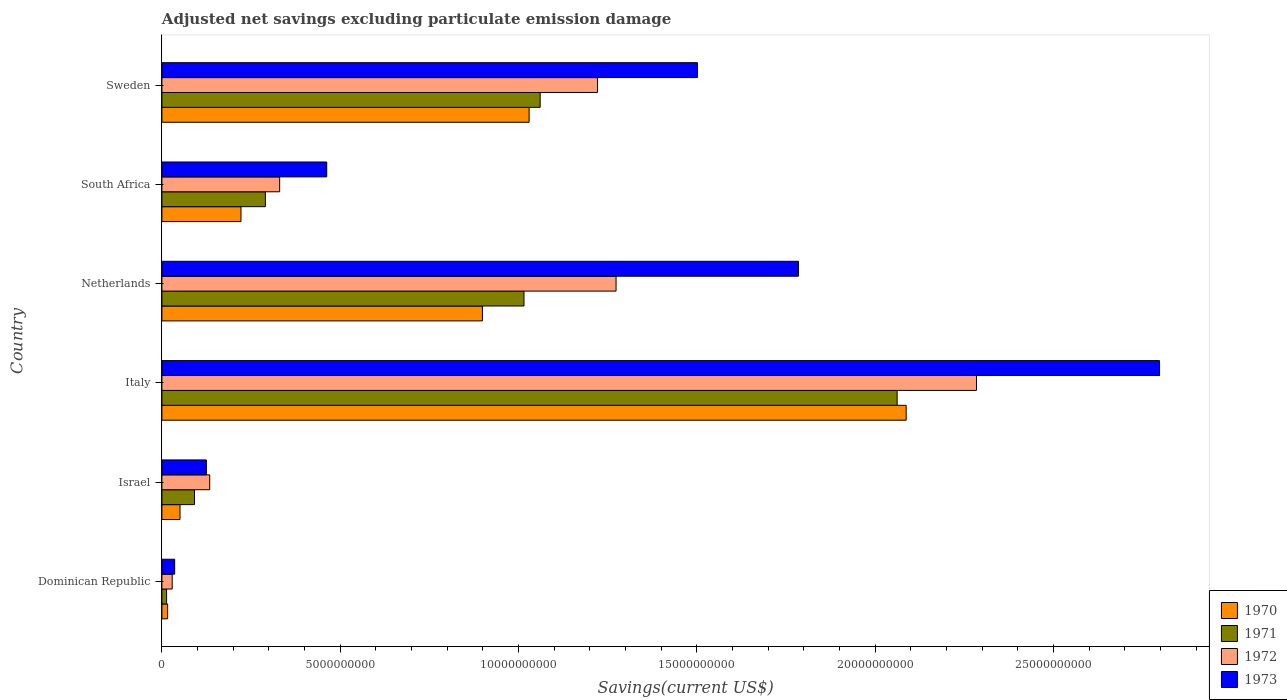How many different coloured bars are there?
Give a very brief answer. 4. How many bars are there on the 4th tick from the top?
Make the answer very short. 4. How many bars are there on the 5th tick from the bottom?
Provide a short and direct response. 4. What is the label of the 3rd group of bars from the top?
Give a very brief answer. Netherlands. In how many cases, is the number of bars for a given country not equal to the number of legend labels?
Make the answer very short. 0. What is the adjusted net savings in 1970 in Netherlands?
Provide a short and direct response. 8.99e+09. Across all countries, what is the maximum adjusted net savings in 1970?
Keep it short and to the point. 2.09e+1. Across all countries, what is the minimum adjusted net savings in 1972?
Provide a succinct answer. 2.89e+08. In which country was the adjusted net savings in 1971 minimum?
Offer a terse response. Dominican Republic. What is the total adjusted net savings in 1971 in the graph?
Give a very brief answer. 4.53e+1. What is the difference between the adjusted net savings in 1972 in Netherlands and that in Sweden?
Offer a very short reply. 5.20e+08. What is the difference between the adjusted net savings in 1971 in Italy and the adjusted net savings in 1972 in Sweden?
Your response must be concise. 8.40e+09. What is the average adjusted net savings in 1971 per country?
Give a very brief answer. 7.55e+09. What is the difference between the adjusted net savings in 1973 and adjusted net savings in 1970 in Israel?
Provide a succinct answer. 7.39e+08. What is the ratio of the adjusted net savings in 1973 in Italy to that in Sweden?
Your answer should be compact. 1.86. What is the difference between the highest and the second highest adjusted net savings in 1971?
Ensure brevity in your answer.  1.00e+1. What is the difference between the highest and the lowest adjusted net savings in 1972?
Ensure brevity in your answer.  2.26e+1. In how many countries, is the adjusted net savings in 1972 greater than the average adjusted net savings in 1972 taken over all countries?
Offer a terse response. 3. Is the sum of the adjusted net savings in 1973 in Netherlands and South Africa greater than the maximum adjusted net savings in 1971 across all countries?
Your response must be concise. Yes. Is it the case that in every country, the sum of the adjusted net savings in 1973 and adjusted net savings in 1971 is greater than the sum of adjusted net savings in 1970 and adjusted net savings in 1972?
Your answer should be compact. No. What does the 2nd bar from the top in South Africa represents?
Your response must be concise. 1972. What does the 2nd bar from the bottom in Dominican Republic represents?
Keep it short and to the point. 1971. Is it the case that in every country, the sum of the adjusted net savings in 1972 and adjusted net savings in 1970 is greater than the adjusted net savings in 1973?
Provide a short and direct response. Yes. Are all the bars in the graph horizontal?
Your response must be concise. Yes. What is the difference between two consecutive major ticks on the X-axis?
Provide a short and direct response. 5.00e+09. Does the graph contain grids?
Your response must be concise. No. How many legend labels are there?
Give a very brief answer. 4. What is the title of the graph?
Make the answer very short. Adjusted net savings excluding particulate emission damage. What is the label or title of the X-axis?
Ensure brevity in your answer.  Savings(current US$). What is the Savings(current US$) of 1970 in Dominican Republic?
Your response must be concise. 1.61e+08. What is the Savings(current US$) of 1971 in Dominican Republic?
Provide a short and direct response. 1.32e+08. What is the Savings(current US$) of 1972 in Dominican Republic?
Provide a short and direct response. 2.89e+08. What is the Savings(current US$) of 1973 in Dominican Republic?
Keep it short and to the point. 3.58e+08. What is the Savings(current US$) in 1970 in Israel?
Your answer should be compact. 5.08e+08. What is the Savings(current US$) of 1971 in Israel?
Make the answer very short. 9.14e+08. What is the Savings(current US$) in 1972 in Israel?
Your answer should be compact. 1.34e+09. What is the Savings(current US$) in 1973 in Israel?
Your answer should be very brief. 1.25e+09. What is the Savings(current US$) of 1970 in Italy?
Your response must be concise. 2.09e+1. What is the Savings(current US$) of 1971 in Italy?
Your answer should be very brief. 2.06e+1. What is the Savings(current US$) of 1972 in Italy?
Your response must be concise. 2.28e+1. What is the Savings(current US$) of 1973 in Italy?
Provide a succinct answer. 2.80e+1. What is the Savings(current US$) of 1970 in Netherlands?
Your response must be concise. 8.99e+09. What is the Savings(current US$) in 1971 in Netherlands?
Offer a very short reply. 1.02e+1. What is the Savings(current US$) of 1972 in Netherlands?
Your answer should be very brief. 1.27e+1. What is the Savings(current US$) in 1973 in Netherlands?
Provide a succinct answer. 1.79e+1. What is the Savings(current US$) of 1970 in South Africa?
Your answer should be very brief. 2.22e+09. What is the Savings(current US$) in 1971 in South Africa?
Provide a succinct answer. 2.90e+09. What is the Savings(current US$) of 1972 in South Africa?
Ensure brevity in your answer.  3.30e+09. What is the Savings(current US$) in 1973 in South Africa?
Make the answer very short. 4.62e+09. What is the Savings(current US$) of 1970 in Sweden?
Offer a very short reply. 1.03e+1. What is the Savings(current US$) of 1971 in Sweden?
Ensure brevity in your answer.  1.06e+1. What is the Savings(current US$) of 1972 in Sweden?
Your answer should be very brief. 1.22e+1. What is the Savings(current US$) in 1973 in Sweden?
Your answer should be very brief. 1.50e+1. Across all countries, what is the maximum Savings(current US$) of 1970?
Offer a terse response. 2.09e+1. Across all countries, what is the maximum Savings(current US$) in 1971?
Make the answer very short. 2.06e+1. Across all countries, what is the maximum Savings(current US$) in 1972?
Make the answer very short. 2.28e+1. Across all countries, what is the maximum Savings(current US$) of 1973?
Offer a terse response. 2.80e+1. Across all countries, what is the minimum Savings(current US$) in 1970?
Offer a terse response. 1.61e+08. Across all countries, what is the minimum Savings(current US$) of 1971?
Ensure brevity in your answer.  1.32e+08. Across all countries, what is the minimum Savings(current US$) of 1972?
Ensure brevity in your answer.  2.89e+08. Across all countries, what is the minimum Savings(current US$) in 1973?
Your answer should be very brief. 3.58e+08. What is the total Savings(current US$) of 1970 in the graph?
Provide a short and direct response. 4.30e+1. What is the total Savings(current US$) in 1971 in the graph?
Keep it short and to the point. 4.53e+1. What is the total Savings(current US$) in 1972 in the graph?
Provide a short and direct response. 5.27e+1. What is the total Savings(current US$) of 1973 in the graph?
Your answer should be compact. 6.71e+1. What is the difference between the Savings(current US$) of 1970 in Dominican Republic and that in Israel?
Keep it short and to the point. -3.47e+08. What is the difference between the Savings(current US$) of 1971 in Dominican Republic and that in Israel?
Your response must be concise. -7.83e+08. What is the difference between the Savings(current US$) of 1972 in Dominican Republic and that in Israel?
Your response must be concise. -1.05e+09. What is the difference between the Savings(current US$) of 1973 in Dominican Republic and that in Israel?
Make the answer very short. -8.89e+08. What is the difference between the Savings(current US$) of 1970 in Dominican Republic and that in Italy?
Make the answer very short. -2.07e+1. What is the difference between the Savings(current US$) of 1971 in Dominican Republic and that in Italy?
Offer a very short reply. -2.05e+1. What is the difference between the Savings(current US$) in 1972 in Dominican Republic and that in Italy?
Offer a terse response. -2.26e+1. What is the difference between the Savings(current US$) in 1973 in Dominican Republic and that in Italy?
Give a very brief answer. -2.76e+1. What is the difference between the Savings(current US$) of 1970 in Dominican Republic and that in Netherlands?
Your answer should be very brief. -8.83e+09. What is the difference between the Savings(current US$) in 1971 in Dominican Republic and that in Netherlands?
Give a very brief answer. -1.00e+1. What is the difference between the Savings(current US$) in 1972 in Dominican Republic and that in Netherlands?
Ensure brevity in your answer.  -1.24e+1. What is the difference between the Savings(current US$) in 1973 in Dominican Republic and that in Netherlands?
Provide a succinct answer. -1.75e+1. What is the difference between the Savings(current US$) in 1970 in Dominican Republic and that in South Africa?
Make the answer very short. -2.06e+09. What is the difference between the Savings(current US$) of 1971 in Dominican Republic and that in South Africa?
Provide a short and direct response. -2.77e+09. What is the difference between the Savings(current US$) of 1972 in Dominican Republic and that in South Africa?
Provide a succinct answer. -3.01e+09. What is the difference between the Savings(current US$) in 1973 in Dominican Republic and that in South Africa?
Provide a short and direct response. -4.26e+09. What is the difference between the Savings(current US$) in 1970 in Dominican Republic and that in Sweden?
Your response must be concise. -1.01e+1. What is the difference between the Savings(current US$) of 1971 in Dominican Republic and that in Sweden?
Keep it short and to the point. -1.05e+1. What is the difference between the Savings(current US$) of 1972 in Dominican Republic and that in Sweden?
Your response must be concise. -1.19e+1. What is the difference between the Savings(current US$) of 1973 in Dominican Republic and that in Sweden?
Your response must be concise. -1.47e+1. What is the difference between the Savings(current US$) in 1970 in Israel and that in Italy?
Provide a short and direct response. -2.04e+1. What is the difference between the Savings(current US$) in 1971 in Israel and that in Italy?
Provide a short and direct response. -1.97e+1. What is the difference between the Savings(current US$) of 1972 in Israel and that in Italy?
Ensure brevity in your answer.  -2.15e+1. What is the difference between the Savings(current US$) of 1973 in Israel and that in Italy?
Make the answer very short. -2.67e+1. What is the difference between the Savings(current US$) of 1970 in Israel and that in Netherlands?
Your response must be concise. -8.48e+09. What is the difference between the Savings(current US$) of 1971 in Israel and that in Netherlands?
Your answer should be compact. -9.24e+09. What is the difference between the Savings(current US$) of 1972 in Israel and that in Netherlands?
Your answer should be compact. -1.14e+1. What is the difference between the Savings(current US$) in 1973 in Israel and that in Netherlands?
Your response must be concise. -1.66e+1. What is the difference between the Savings(current US$) in 1970 in Israel and that in South Africa?
Give a very brief answer. -1.71e+09. What is the difference between the Savings(current US$) of 1971 in Israel and that in South Africa?
Provide a succinct answer. -1.99e+09. What is the difference between the Savings(current US$) in 1972 in Israel and that in South Africa?
Your response must be concise. -1.96e+09. What is the difference between the Savings(current US$) in 1973 in Israel and that in South Africa?
Keep it short and to the point. -3.38e+09. What is the difference between the Savings(current US$) in 1970 in Israel and that in Sweden?
Provide a short and direct response. -9.79e+09. What is the difference between the Savings(current US$) in 1971 in Israel and that in Sweden?
Ensure brevity in your answer.  -9.69e+09. What is the difference between the Savings(current US$) of 1972 in Israel and that in Sweden?
Offer a very short reply. -1.09e+1. What is the difference between the Savings(current US$) of 1973 in Israel and that in Sweden?
Your answer should be very brief. -1.38e+1. What is the difference between the Savings(current US$) in 1970 in Italy and that in Netherlands?
Provide a short and direct response. 1.19e+1. What is the difference between the Savings(current US$) of 1971 in Italy and that in Netherlands?
Your response must be concise. 1.05e+1. What is the difference between the Savings(current US$) in 1972 in Italy and that in Netherlands?
Offer a terse response. 1.01e+1. What is the difference between the Savings(current US$) of 1973 in Italy and that in Netherlands?
Keep it short and to the point. 1.01e+1. What is the difference between the Savings(current US$) of 1970 in Italy and that in South Africa?
Make the answer very short. 1.87e+1. What is the difference between the Savings(current US$) of 1971 in Italy and that in South Africa?
Give a very brief answer. 1.77e+1. What is the difference between the Savings(current US$) in 1972 in Italy and that in South Africa?
Ensure brevity in your answer.  1.95e+1. What is the difference between the Savings(current US$) in 1973 in Italy and that in South Africa?
Ensure brevity in your answer.  2.34e+1. What is the difference between the Savings(current US$) in 1970 in Italy and that in Sweden?
Your response must be concise. 1.06e+1. What is the difference between the Savings(current US$) of 1971 in Italy and that in Sweden?
Make the answer very short. 1.00e+1. What is the difference between the Savings(current US$) of 1972 in Italy and that in Sweden?
Provide a short and direct response. 1.06e+1. What is the difference between the Savings(current US$) of 1973 in Italy and that in Sweden?
Provide a succinct answer. 1.30e+1. What is the difference between the Savings(current US$) in 1970 in Netherlands and that in South Africa?
Keep it short and to the point. 6.77e+09. What is the difference between the Savings(current US$) of 1971 in Netherlands and that in South Africa?
Your answer should be compact. 7.25e+09. What is the difference between the Savings(current US$) in 1972 in Netherlands and that in South Africa?
Your answer should be very brief. 9.43e+09. What is the difference between the Savings(current US$) of 1973 in Netherlands and that in South Africa?
Provide a succinct answer. 1.32e+1. What is the difference between the Savings(current US$) in 1970 in Netherlands and that in Sweden?
Your response must be concise. -1.31e+09. What is the difference between the Savings(current US$) of 1971 in Netherlands and that in Sweden?
Offer a terse response. -4.54e+08. What is the difference between the Savings(current US$) of 1972 in Netherlands and that in Sweden?
Make the answer very short. 5.20e+08. What is the difference between the Savings(current US$) of 1973 in Netherlands and that in Sweden?
Your answer should be very brief. 2.83e+09. What is the difference between the Savings(current US$) in 1970 in South Africa and that in Sweden?
Make the answer very short. -8.08e+09. What is the difference between the Savings(current US$) in 1971 in South Africa and that in Sweden?
Your response must be concise. -7.70e+09. What is the difference between the Savings(current US$) of 1972 in South Africa and that in Sweden?
Your response must be concise. -8.91e+09. What is the difference between the Savings(current US$) of 1973 in South Africa and that in Sweden?
Give a very brief answer. -1.04e+1. What is the difference between the Savings(current US$) of 1970 in Dominican Republic and the Savings(current US$) of 1971 in Israel?
Ensure brevity in your answer.  -7.53e+08. What is the difference between the Savings(current US$) of 1970 in Dominican Republic and the Savings(current US$) of 1972 in Israel?
Provide a succinct answer. -1.18e+09. What is the difference between the Savings(current US$) of 1970 in Dominican Republic and the Savings(current US$) of 1973 in Israel?
Give a very brief answer. -1.09e+09. What is the difference between the Savings(current US$) in 1971 in Dominican Republic and the Savings(current US$) in 1972 in Israel?
Your response must be concise. -1.21e+09. What is the difference between the Savings(current US$) in 1971 in Dominican Republic and the Savings(current US$) in 1973 in Israel?
Give a very brief answer. -1.12e+09. What is the difference between the Savings(current US$) of 1972 in Dominican Republic and the Savings(current US$) of 1973 in Israel?
Offer a terse response. -9.58e+08. What is the difference between the Savings(current US$) of 1970 in Dominican Republic and the Savings(current US$) of 1971 in Italy?
Provide a succinct answer. -2.05e+1. What is the difference between the Savings(current US$) in 1970 in Dominican Republic and the Savings(current US$) in 1972 in Italy?
Ensure brevity in your answer.  -2.27e+1. What is the difference between the Savings(current US$) in 1970 in Dominican Republic and the Savings(current US$) in 1973 in Italy?
Provide a succinct answer. -2.78e+1. What is the difference between the Savings(current US$) in 1971 in Dominican Republic and the Savings(current US$) in 1972 in Italy?
Make the answer very short. -2.27e+1. What is the difference between the Savings(current US$) of 1971 in Dominican Republic and the Savings(current US$) of 1973 in Italy?
Provide a succinct answer. -2.78e+1. What is the difference between the Savings(current US$) of 1972 in Dominican Republic and the Savings(current US$) of 1973 in Italy?
Ensure brevity in your answer.  -2.77e+1. What is the difference between the Savings(current US$) in 1970 in Dominican Republic and the Savings(current US$) in 1971 in Netherlands?
Offer a very short reply. -9.99e+09. What is the difference between the Savings(current US$) of 1970 in Dominican Republic and the Savings(current US$) of 1972 in Netherlands?
Make the answer very short. -1.26e+1. What is the difference between the Savings(current US$) in 1970 in Dominican Republic and the Savings(current US$) in 1973 in Netherlands?
Your answer should be very brief. -1.77e+1. What is the difference between the Savings(current US$) in 1971 in Dominican Republic and the Savings(current US$) in 1972 in Netherlands?
Your answer should be very brief. -1.26e+1. What is the difference between the Savings(current US$) of 1971 in Dominican Republic and the Savings(current US$) of 1973 in Netherlands?
Offer a terse response. -1.77e+1. What is the difference between the Savings(current US$) of 1972 in Dominican Republic and the Savings(current US$) of 1973 in Netherlands?
Provide a short and direct response. -1.76e+1. What is the difference between the Savings(current US$) of 1970 in Dominican Republic and the Savings(current US$) of 1971 in South Africa?
Offer a terse response. -2.74e+09. What is the difference between the Savings(current US$) in 1970 in Dominican Republic and the Savings(current US$) in 1972 in South Africa?
Offer a terse response. -3.14e+09. What is the difference between the Savings(current US$) in 1970 in Dominican Republic and the Savings(current US$) in 1973 in South Africa?
Your answer should be compact. -4.46e+09. What is the difference between the Savings(current US$) of 1971 in Dominican Republic and the Savings(current US$) of 1972 in South Africa?
Keep it short and to the point. -3.17e+09. What is the difference between the Savings(current US$) of 1971 in Dominican Republic and the Savings(current US$) of 1973 in South Africa?
Offer a very short reply. -4.49e+09. What is the difference between the Savings(current US$) in 1972 in Dominican Republic and the Savings(current US$) in 1973 in South Africa?
Make the answer very short. -4.33e+09. What is the difference between the Savings(current US$) of 1970 in Dominican Republic and the Savings(current US$) of 1971 in Sweden?
Make the answer very short. -1.04e+1. What is the difference between the Savings(current US$) of 1970 in Dominican Republic and the Savings(current US$) of 1972 in Sweden?
Offer a very short reply. -1.21e+1. What is the difference between the Savings(current US$) in 1970 in Dominican Republic and the Savings(current US$) in 1973 in Sweden?
Keep it short and to the point. -1.49e+1. What is the difference between the Savings(current US$) in 1971 in Dominican Republic and the Savings(current US$) in 1972 in Sweden?
Your response must be concise. -1.21e+1. What is the difference between the Savings(current US$) in 1971 in Dominican Republic and the Savings(current US$) in 1973 in Sweden?
Your answer should be compact. -1.49e+1. What is the difference between the Savings(current US$) in 1972 in Dominican Republic and the Savings(current US$) in 1973 in Sweden?
Keep it short and to the point. -1.47e+1. What is the difference between the Savings(current US$) of 1970 in Israel and the Savings(current US$) of 1971 in Italy?
Keep it short and to the point. -2.01e+1. What is the difference between the Savings(current US$) in 1970 in Israel and the Savings(current US$) in 1972 in Italy?
Give a very brief answer. -2.23e+1. What is the difference between the Savings(current US$) in 1970 in Israel and the Savings(current US$) in 1973 in Italy?
Make the answer very short. -2.75e+1. What is the difference between the Savings(current US$) of 1971 in Israel and the Savings(current US$) of 1972 in Italy?
Offer a very short reply. -2.19e+1. What is the difference between the Savings(current US$) in 1971 in Israel and the Savings(current US$) in 1973 in Italy?
Your answer should be very brief. -2.71e+1. What is the difference between the Savings(current US$) in 1972 in Israel and the Savings(current US$) in 1973 in Italy?
Your answer should be compact. -2.66e+1. What is the difference between the Savings(current US$) of 1970 in Israel and the Savings(current US$) of 1971 in Netherlands?
Offer a terse response. -9.65e+09. What is the difference between the Savings(current US$) of 1970 in Israel and the Savings(current US$) of 1972 in Netherlands?
Offer a very short reply. -1.22e+1. What is the difference between the Savings(current US$) of 1970 in Israel and the Savings(current US$) of 1973 in Netherlands?
Provide a short and direct response. -1.73e+1. What is the difference between the Savings(current US$) of 1971 in Israel and the Savings(current US$) of 1972 in Netherlands?
Offer a very short reply. -1.18e+1. What is the difference between the Savings(current US$) of 1971 in Israel and the Savings(current US$) of 1973 in Netherlands?
Make the answer very short. -1.69e+1. What is the difference between the Savings(current US$) of 1972 in Israel and the Savings(current US$) of 1973 in Netherlands?
Provide a short and direct response. -1.65e+1. What is the difference between the Savings(current US$) in 1970 in Israel and the Savings(current US$) in 1971 in South Africa?
Provide a short and direct response. -2.39e+09. What is the difference between the Savings(current US$) in 1970 in Israel and the Savings(current US$) in 1972 in South Africa?
Your response must be concise. -2.79e+09. What is the difference between the Savings(current US$) in 1970 in Israel and the Savings(current US$) in 1973 in South Africa?
Keep it short and to the point. -4.11e+09. What is the difference between the Savings(current US$) of 1971 in Israel and the Savings(current US$) of 1972 in South Africa?
Make the answer very short. -2.39e+09. What is the difference between the Savings(current US$) in 1971 in Israel and the Savings(current US$) in 1973 in South Africa?
Your response must be concise. -3.71e+09. What is the difference between the Savings(current US$) in 1972 in Israel and the Savings(current US$) in 1973 in South Africa?
Keep it short and to the point. -3.28e+09. What is the difference between the Savings(current US$) of 1970 in Israel and the Savings(current US$) of 1971 in Sweden?
Provide a short and direct response. -1.01e+1. What is the difference between the Savings(current US$) in 1970 in Israel and the Savings(current US$) in 1972 in Sweden?
Keep it short and to the point. -1.17e+1. What is the difference between the Savings(current US$) of 1970 in Israel and the Savings(current US$) of 1973 in Sweden?
Provide a short and direct response. -1.45e+1. What is the difference between the Savings(current US$) in 1971 in Israel and the Savings(current US$) in 1972 in Sweden?
Your answer should be compact. -1.13e+1. What is the difference between the Savings(current US$) of 1971 in Israel and the Savings(current US$) of 1973 in Sweden?
Your answer should be compact. -1.41e+1. What is the difference between the Savings(current US$) of 1972 in Israel and the Savings(current US$) of 1973 in Sweden?
Keep it short and to the point. -1.37e+1. What is the difference between the Savings(current US$) of 1970 in Italy and the Savings(current US$) of 1971 in Netherlands?
Provide a short and direct response. 1.07e+1. What is the difference between the Savings(current US$) of 1970 in Italy and the Savings(current US$) of 1972 in Netherlands?
Keep it short and to the point. 8.14e+09. What is the difference between the Savings(current US$) in 1970 in Italy and the Savings(current US$) in 1973 in Netherlands?
Your response must be concise. 3.02e+09. What is the difference between the Savings(current US$) in 1971 in Italy and the Savings(current US$) in 1972 in Netherlands?
Give a very brief answer. 7.88e+09. What is the difference between the Savings(current US$) of 1971 in Italy and the Savings(current US$) of 1973 in Netherlands?
Ensure brevity in your answer.  2.77e+09. What is the difference between the Savings(current US$) in 1972 in Italy and the Savings(current US$) in 1973 in Netherlands?
Ensure brevity in your answer.  4.99e+09. What is the difference between the Savings(current US$) of 1970 in Italy and the Savings(current US$) of 1971 in South Africa?
Your answer should be very brief. 1.80e+1. What is the difference between the Savings(current US$) of 1970 in Italy and the Savings(current US$) of 1972 in South Africa?
Your answer should be compact. 1.76e+1. What is the difference between the Savings(current US$) in 1970 in Italy and the Savings(current US$) in 1973 in South Africa?
Offer a very short reply. 1.62e+1. What is the difference between the Savings(current US$) of 1971 in Italy and the Savings(current US$) of 1972 in South Africa?
Your answer should be very brief. 1.73e+1. What is the difference between the Savings(current US$) of 1971 in Italy and the Savings(current US$) of 1973 in South Africa?
Ensure brevity in your answer.  1.60e+1. What is the difference between the Savings(current US$) of 1972 in Italy and the Savings(current US$) of 1973 in South Africa?
Your answer should be very brief. 1.82e+1. What is the difference between the Savings(current US$) in 1970 in Italy and the Savings(current US$) in 1971 in Sweden?
Your answer should be compact. 1.03e+1. What is the difference between the Savings(current US$) in 1970 in Italy and the Savings(current US$) in 1972 in Sweden?
Provide a short and direct response. 8.66e+09. What is the difference between the Savings(current US$) of 1970 in Italy and the Savings(current US$) of 1973 in Sweden?
Ensure brevity in your answer.  5.85e+09. What is the difference between the Savings(current US$) of 1971 in Italy and the Savings(current US$) of 1972 in Sweden?
Give a very brief answer. 8.40e+09. What is the difference between the Savings(current US$) in 1971 in Italy and the Savings(current US$) in 1973 in Sweden?
Your response must be concise. 5.60e+09. What is the difference between the Savings(current US$) of 1972 in Italy and the Savings(current US$) of 1973 in Sweden?
Your answer should be very brief. 7.83e+09. What is the difference between the Savings(current US$) of 1970 in Netherlands and the Savings(current US$) of 1971 in South Africa?
Give a very brief answer. 6.09e+09. What is the difference between the Savings(current US$) of 1970 in Netherlands and the Savings(current US$) of 1972 in South Africa?
Ensure brevity in your answer.  5.69e+09. What is the difference between the Savings(current US$) of 1970 in Netherlands and the Savings(current US$) of 1973 in South Africa?
Give a very brief answer. 4.37e+09. What is the difference between the Savings(current US$) in 1971 in Netherlands and the Savings(current US$) in 1972 in South Africa?
Ensure brevity in your answer.  6.85e+09. What is the difference between the Savings(current US$) in 1971 in Netherlands and the Savings(current US$) in 1973 in South Africa?
Keep it short and to the point. 5.53e+09. What is the difference between the Savings(current US$) in 1972 in Netherlands and the Savings(current US$) in 1973 in South Africa?
Offer a very short reply. 8.11e+09. What is the difference between the Savings(current US$) in 1970 in Netherlands and the Savings(current US$) in 1971 in Sweden?
Ensure brevity in your answer.  -1.62e+09. What is the difference between the Savings(current US$) in 1970 in Netherlands and the Savings(current US$) in 1972 in Sweden?
Offer a very short reply. -3.23e+09. What is the difference between the Savings(current US$) in 1970 in Netherlands and the Savings(current US$) in 1973 in Sweden?
Keep it short and to the point. -6.03e+09. What is the difference between the Savings(current US$) of 1971 in Netherlands and the Savings(current US$) of 1972 in Sweden?
Provide a succinct answer. -2.06e+09. What is the difference between the Savings(current US$) of 1971 in Netherlands and the Savings(current US$) of 1973 in Sweden?
Provide a succinct answer. -4.86e+09. What is the difference between the Savings(current US$) of 1972 in Netherlands and the Savings(current US$) of 1973 in Sweden?
Provide a succinct answer. -2.28e+09. What is the difference between the Savings(current US$) of 1970 in South Africa and the Savings(current US$) of 1971 in Sweden?
Your response must be concise. -8.39e+09. What is the difference between the Savings(current US$) in 1970 in South Africa and the Savings(current US$) in 1972 in Sweden?
Make the answer very short. -1.00e+1. What is the difference between the Savings(current US$) of 1970 in South Africa and the Savings(current US$) of 1973 in Sweden?
Your response must be concise. -1.28e+1. What is the difference between the Savings(current US$) of 1971 in South Africa and the Savings(current US$) of 1972 in Sweden?
Offer a terse response. -9.31e+09. What is the difference between the Savings(current US$) in 1971 in South Africa and the Savings(current US$) in 1973 in Sweden?
Ensure brevity in your answer.  -1.21e+1. What is the difference between the Savings(current US$) in 1972 in South Africa and the Savings(current US$) in 1973 in Sweden?
Your response must be concise. -1.17e+1. What is the average Savings(current US$) in 1970 per country?
Give a very brief answer. 7.17e+09. What is the average Savings(current US$) in 1971 per country?
Offer a terse response. 7.55e+09. What is the average Savings(current US$) of 1972 per country?
Make the answer very short. 8.79e+09. What is the average Savings(current US$) of 1973 per country?
Offer a terse response. 1.12e+1. What is the difference between the Savings(current US$) in 1970 and Savings(current US$) in 1971 in Dominican Republic?
Give a very brief answer. 2.96e+07. What is the difference between the Savings(current US$) of 1970 and Savings(current US$) of 1972 in Dominican Republic?
Offer a terse response. -1.28e+08. What is the difference between the Savings(current US$) of 1970 and Savings(current US$) of 1973 in Dominican Republic?
Your answer should be compact. -1.97e+08. What is the difference between the Savings(current US$) in 1971 and Savings(current US$) in 1972 in Dominican Republic?
Keep it short and to the point. -1.57e+08. What is the difference between the Savings(current US$) in 1971 and Savings(current US$) in 1973 in Dominican Republic?
Your answer should be very brief. -2.27e+08. What is the difference between the Savings(current US$) of 1972 and Savings(current US$) of 1973 in Dominican Republic?
Offer a terse response. -6.95e+07. What is the difference between the Savings(current US$) in 1970 and Savings(current US$) in 1971 in Israel?
Offer a terse response. -4.06e+08. What is the difference between the Savings(current US$) of 1970 and Savings(current US$) of 1972 in Israel?
Provide a succinct answer. -8.33e+08. What is the difference between the Savings(current US$) of 1970 and Savings(current US$) of 1973 in Israel?
Your answer should be compact. -7.39e+08. What is the difference between the Savings(current US$) of 1971 and Savings(current US$) of 1972 in Israel?
Your answer should be compact. -4.27e+08. What is the difference between the Savings(current US$) in 1971 and Savings(current US$) in 1973 in Israel?
Make the answer very short. -3.33e+08. What is the difference between the Savings(current US$) of 1972 and Savings(current US$) of 1973 in Israel?
Offer a terse response. 9.40e+07. What is the difference between the Savings(current US$) of 1970 and Savings(current US$) of 1971 in Italy?
Provide a succinct answer. 2.53e+08. What is the difference between the Savings(current US$) in 1970 and Savings(current US$) in 1972 in Italy?
Ensure brevity in your answer.  -1.97e+09. What is the difference between the Savings(current US$) of 1970 and Savings(current US$) of 1973 in Italy?
Your answer should be compact. -7.11e+09. What is the difference between the Savings(current US$) of 1971 and Savings(current US$) of 1972 in Italy?
Provide a succinct answer. -2.23e+09. What is the difference between the Savings(current US$) in 1971 and Savings(current US$) in 1973 in Italy?
Your answer should be very brief. -7.36e+09. What is the difference between the Savings(current US$) in 1972 and Savings(current US$) in 1973 in Italy?
Your response must be concise. -5.13e+09. What is the difference between the Savings(current US$) in 1970 and Savings(current US$) in 1971 in Netherlands?
Make the answer very short. -1.17e+09. What is the difference between the Savings(current US$) of 1970 and Savings(current US$) of 1972 in Netherlands?
Your answer should be compact. -3.75e+09. What is the difference between the Savings(current US$) of 1970 and Savings(current US$) of 1973 in Netherlands?
Your response must be concise. -8.86e+09. What is the difference between the Savings(current US$) of 1971 and Savings(current US$) of 1972 in Netherlands?
Your answer should be compact. -2.58e+09. What is the difference between the Savings(current US$) of 1971 and Savings(current US$) of 1973 in Netherlands?
Offer a terse response. -7.70e+09. What is the difference between the Savings(current US$) of 1972 and Savings(current US$) of 1973 in Netherlands?
Make the answer very short. -5.11e+09. What is the difference between the Savings(current US$) in 1970 and Savings(current US$) in 1971 in South Africa?
Your answer should be very brief. -6.85e+08. What is the difference between the Savings(current US$) in 1970 and Savings(current US$) in 1972 in South Africa?
Make the answer very short. -1.08e+09. What is the difference between the Savings(current US$) in 1970 and Savings(current US$) in 1973 in South Africa?
Ensure brevity in your answer.  -2.40e+09. What is the difference between the Savings(current US$) in 1971 and Savings(current US$) in 1972 in South Africa?
Provide a short and direct response. -4.00e+08. What is the difference between the Savings(current US$) in 1971 and Savings(current US$) in 1973 in South Africa?
Offer a terse response. -1.72e+09. What is the difference between the Savings(current US$) of 1972 and Savings(current US$) of 1973 in South Africa?
Offer a terse response. -1.32e+09. What is the difference between the Savings(current US$) of 1970 and Savings(current US$) of 1971 in Sweden?
Ensure brevity in your answer.  -3.10e+08. What is the difference between the Savings(current US$) in 1970 and Savings(current US$) in 1972 in Sweden?
Keep it short and to the point. -1.92e+09. What is the difference between the Savings(current US$) of 1970 and Savings(current US$) of 1973 in Sweden?
Give a very brief answer. -4.72e+09. What is the difference between the Savings(current US$) of 1971 and Savings(current US$) of 1972 in Sweden?
Keep it short and to the point. -1.61e+09. What is the difference between the Savings(current US$) in 1971 and Savings(current US$) in 1973 in Sweden?
Keep it short and to the point. -4.41e+09. What is the difference between the Savings(current US$) of 1972 and Savings(current US$) of 1973 in Sweden?
Provide a short and direct response. -2.80e+09. What is the ratio of the Savings(current US$) in 1970 in Dominican Republic to that in Israel?
Keep it short and to the point. 0.32. What is the ratio of the Savings(current US$) in 1971 in Dominican Republic to that in Israel?
Your answer should be very brief. 0.14. What is the ratio of the Savings(current US$) in 1972 in Dominican Republic to that in Israel?
Your answer should be very brief. 0.22. What is the ratio of the Savings(current US$) of 1973 in Dominican Republic to that in Israel?
Keep it short and to the point. 0.29. What is the ratio of the Savings(current US$) of 1970 in Dominican Republic to that in Italy?
Give a very brief answer. 0.01. What is the ratio of the Savings(current US$) of 1971 in Dominican Republic to that in Italy?
Your answer should be very brief. 0.01. What is the ratio of the Savings(current US$) of 1972 in Dominican Republic to that in Italy?
Your answer should be very brief. 0.01. What is the ratio of the Savings(current US$) of 1973 in Dominican Republic to that in Italy?
Provide a short and direct response. 0.01. What is the ratio of the Savings(current US$) in 1970 in Dominican Republic to that in Netherlands?
Offer a very short reply. 0.02. What is the ratio of the Savings(current US$) of 1971 in Dominican Republic to that in Netherlands?
Your answer should be very brief. 0.01. What is the ratio of the Savings(current US$) in 1972 in Dominican Republic to that in Netherlands?
Give a very brief answer. 0.02. What is the ratio of the Savings(current US$) of 1973 in Dominican Republic to that in Netherlands?
Give a very brief answer. 0.02. What is the ratio of the Savings(current US$) in 1970 in Dominican Republic to that in South Africa?
Provide a succinct answer. 0.07. What is the ratio of the Savings(current US$) in 1971 in Dominican Republic to that in South Africa?
Ensure brevity in your answer.  0.05. What is the ratio of the Savings(current US$) of 1972 in Dominican Republic to that in South Africa?
Provide a short and direct response. 0.09. What is the ratio of the Savings(current US$) in 1973 in Dominican Republic to that in South Africa?
Offer a very short reply. 0.08. What is the ratio of the Savings(current US$) in 1970 in Dominican Republic to that in Sweden?
Keep it short and to the point. 0.02. What is the ratio of the Savings(current US$) of 1971 in Dominican Republic to that in Sweden?
Offer a terse response. 0.01. What is the ratio of the Savings(current US$) in 1972 in Dominican Republic to that in Sweden?
Make the answer very short. 0.02. What is the ratio of the Savings(current US$) of 1973 in Dominican Republic to that in Sweden?
Offer a terse response. 0.02. What is the ratio of the Savings(current US$) in 1970 in Israel to that in Italy?
Offer a terse response. 0.02. What is the ratio of the Savings(current US$) in 1971 in Israel to that in Italy?
Make the answer very short. 0.04. What is the ratio of the Savings(current US$) in 1972 in Israel to that in Italy?
Give a very brief answer. 0.06. What is the ratio of the Savings(current US$) of 1973 in Israel to that in Italy?
Your answer should be very brief. 0.04. What is the ratio of the Savings(current US$) in 1970 in Israel to that in Netherlands?
Your response must be concise. 0.06. What is the ratio of the Savings(current US$) of 1971 in Israel to that in Netherlands?
Offer a terse response. 0.09. What is the ratio of the Savings(current US$) in 1972 in Israel to that in Netherlands?
Provide a succinct answer. 0.11. What is the ratio of the Savings(current US$) in 1973 in Israel to that in Netherlands?
Provide a short and direct response. 0.07. What is the ratio of the Savings(current US$) in 1970 in Israel to that in South Africa?
Provide a succinct answer. 0.23. What is the ratio of the Savings(current US$) in 1971 in Israel to that in South Africa?
Keep it short and to the point. 0.32. What is the ratio of the Savings(current US$) in 1972 in Israel to that in South Africa?
Your answer should be very brief. 0.41. What is the ratio of the Savings(current US$) in 1973 in Israel to that in South Africa?
Ensure brevity in your answer.  0.27. What is the ratio of the Savings(current US$) in 1970 in Israel to that in Sweden?
Give a very brief answer. 0.05. What is the ratio of the Savings(current US$) in 1971 in Israel to that in Sweden?
Ensure brevity in your answer.  0.09. What is the ratio of the Savings(current US$) of 1972 in Israel to that in Sweden?
Your answer should be compact. 0.11. What is the ratio of the Savings(current US$) of 1973 in Israel to that in Sweden?
Provide a succinct answer. 0.08. What is the ratio of the Savings(current US$) of 1970 in Italy to that in Netherlands?
Offer a very short reply. 2.32. What is the ratio of the Savings(current US$) of 1971 in Italy to that in Netherlands?
Your answer should be compact. 2.03. What is the ratio of the Savings(current US$) in 1972 in Italy to that in Netherlands?
Provide a succinct answer. 1.79. What is the ratio of the Savings(current US$) in 1973 in Italy to that in Netherlands?
Your answer should be very brief. 1.57. What is the ratio of the Savings(current US$) of 1970 in Italy to that in South Africa?
Give a very brief answer. 9.41. What is the ratio of the Savings(current US$) in 1971 in Italy to that in South Africa?
Offer a terse response. 7.1. What is the ratio of the Savings(current US$) in 1972 in Italy to that in South Africa?
Make the answer very short. 6.92. What is the ratio of the Savings(current US$) of 1973 in Italy to that in South Africa?
Provide a succinct answer. 6.05. What is the ratio of the Savings(current US$) in 1970 in Italy to that in Sweden?
Make the answer very short. 2.03. What is the ratio of the Savings(current US$) of 1971 in Italy to that in Sweden?
Your answer should be compact. 1.94. What is the ratio of the Savings(current US$) in 1972 in Italy to that in Sweden?
Make the answer very short. 1.87. What is the ratio of the Savings(current US$) in 1973 in Italy to that in Sweden?
Provide a short and direct response. 1.86. What is the ratio of the Savings(current US$) in 1970 in Netherlands to that in South Africa?
Provide a succinct answer. 4.05. What is the ratio of the Savings(current US$) in 1971 in Netherlands to that in South Africa?
Ensure brevity in your answer.  3.5. What is the ratio of the Savings(current US$) of 1972 in Netherlands to that in South Africa?
Your answer should be compact. 3.86. What is the ratio of the Savings(current US$) of 1973 in Netherlands to that in South Africa?
Make the answer very short. 3.86. What is the ratio of the Savings(current US$) in 1970 in Netherlands to that in Sweden?
Your response must be concise. 0.87. What is the ratio of the Savings(current US$) in 1971 in Netherlands to that in Sweden?
Give a very brief answer. 0.96. What is the ratio of the Savings(current US$) of 1972 in Netherlands to that in Sweden?
Make the answer very short. 1.04. What is the ratio of the Savings(current US$) of 1973 in Netherlands to that in Sweden?
Make the answer very short. 1.19. What is the ratio of the Savings(current US$) in 1970 in South Africa to that in Sweden?
Provide a short and direct response. 0.22. What is the ratio of the Savings(current US$) of 1971 in South Africa to that in Sweden?
Offer a terse response. 0.27. What is the ratio of the Savings(current US$) of 1972 in South Africa to that in Sweden?
Your answer should be very brief. 0.27. What is the ratio of the Savings(current US$) of 1973 in South Africa to that in Sweden?
Make the answer very short. 0.31. What is the difference between the highest and the second highest Savings(current US$) of 1970?
Your answer should be compact. 1.06e+1. What is the difference between the highest and the second highest Savings(current US$) in 1971?
Offer a very short reply. 1.00e+1. What is the difference between the highest and the second highest Savings(current US$) of 1972?
Provide a short and direct response. 1.01e+1. What is the difference between the highest and the second highest Savings(current US$) of 1973?
Your response must be concise. 1.01e+1. What is the difference between the highest and the lowest Savings(current US$) in 1970?
Make the answer very short. 2.07e+1. What is the difference between the highest and the lowest Savings(current US$) in 1971?
Provide a short and direct response. 2.05e+1. What is the difference between the highest and the lowest Savings(current US$) of 1972?
Make the answer very short. 2.26e+1. What is the difference between the highest and the lowest Savings(current US$) in 1973?
Your answer should be very brief. 2.76e+1. 